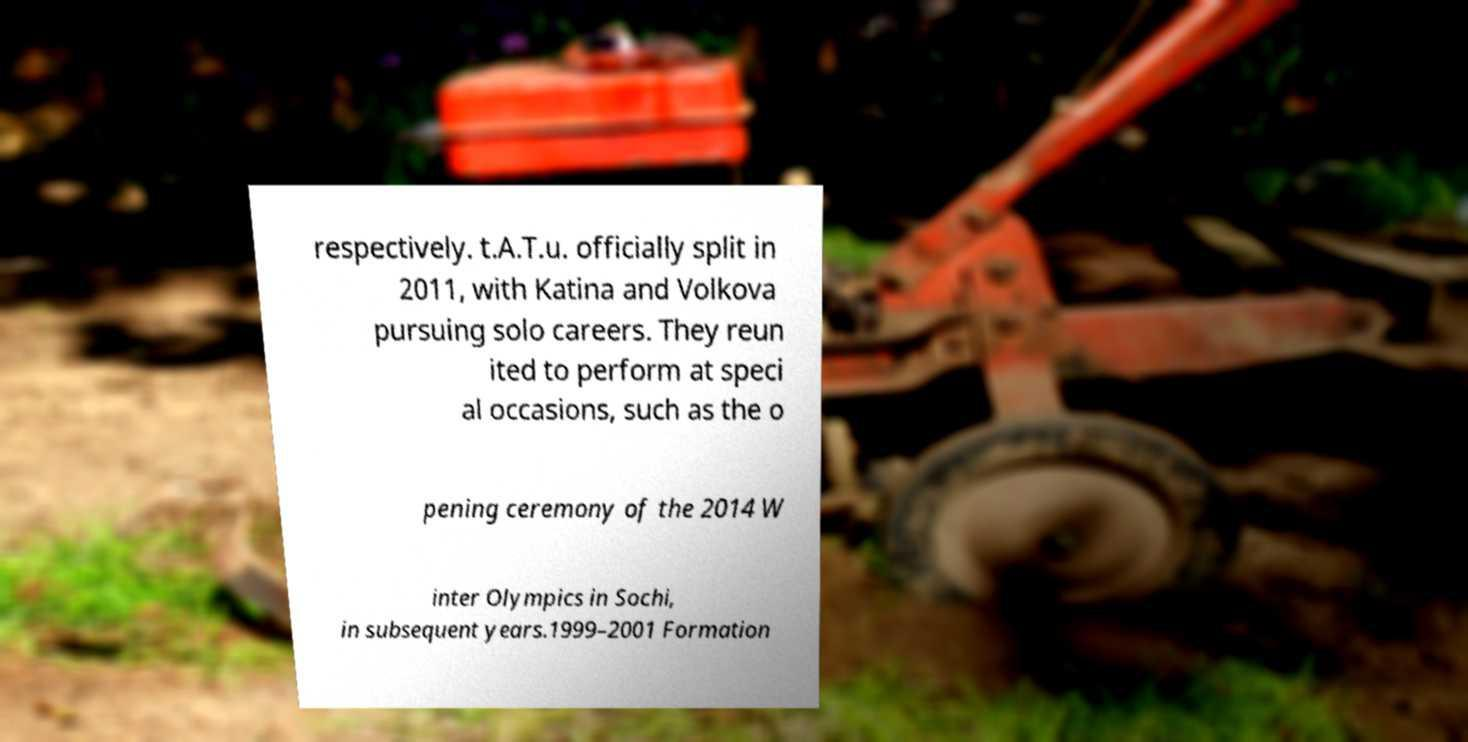Could you extract and type out the text from this image? respectively. t.A.T.u. officially split in 2011, with Katina and Volkova pursuing solo careers. They reun ited to perform at speci al occasions, such as the o pening ceremony of the 2014 W inter Olympics in Sochi, in subsequent years.1999–2001 Formation 